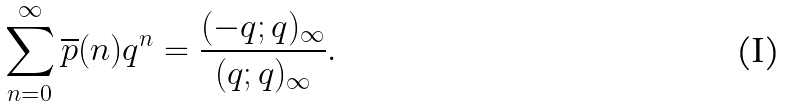<formula> <loc_0><loc_0><loc_500><loc_500>\sum _ { n = 0 } ^ { \infty } \overline { p } ( n ) q ^ { n } = \frac { ( - q ; q ) _ { \infty } } { ( q ; q ) _ { \infty } } .</formula> 